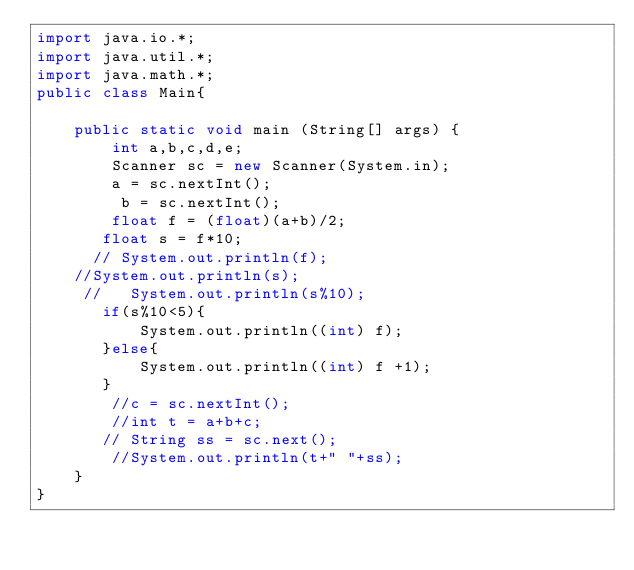Convert code to text. <code><loc_0><loc_0><loc_500><loc_500><_Java_>import java.io.*;
import java.util.*;
import java.math.*;
public class Main{
    
    public static void main (String[] args) {
        int a,b,c,d,e;
        Scanner sc = new Scanner(System.in);
        a = sc.nextInt();
         b = sc.nextInt();
        float f = (float)(a+b)/2;
       float s = f*10;
      // System.out.println(f);
    //System.out.println(s);
     //   System.out.println(s%10);
       if(s%10<5){
           System.out.println((int) f);
       }else{
           System.out.println((int) f +1);
       }
        //c = sc.nextInt();
        //int t = a+b+c;
       // String ss = sc.next();
        //System.out.println(t+" "+ss);
    }
}</code> 